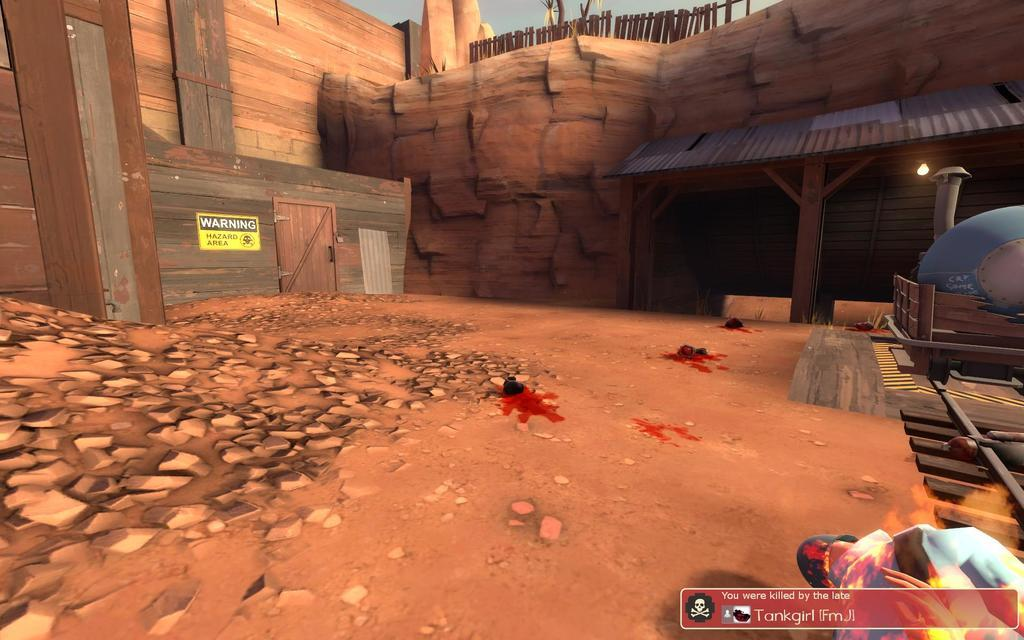What type of picture is featured in the image? There is an animated picture of a house in the image. What natural elements can be seen in the image? There are rocks in the image. What is attached to the rocks in the image? There is a board with text in the image. Who is present in the image? There is a person in the image. Where can additional text be found in the image? There is text in the bottom right corner of the image. What type of yam is being ordered by the person in the image? There is no yam present in the image, nor is there any indication of an order being placed. 